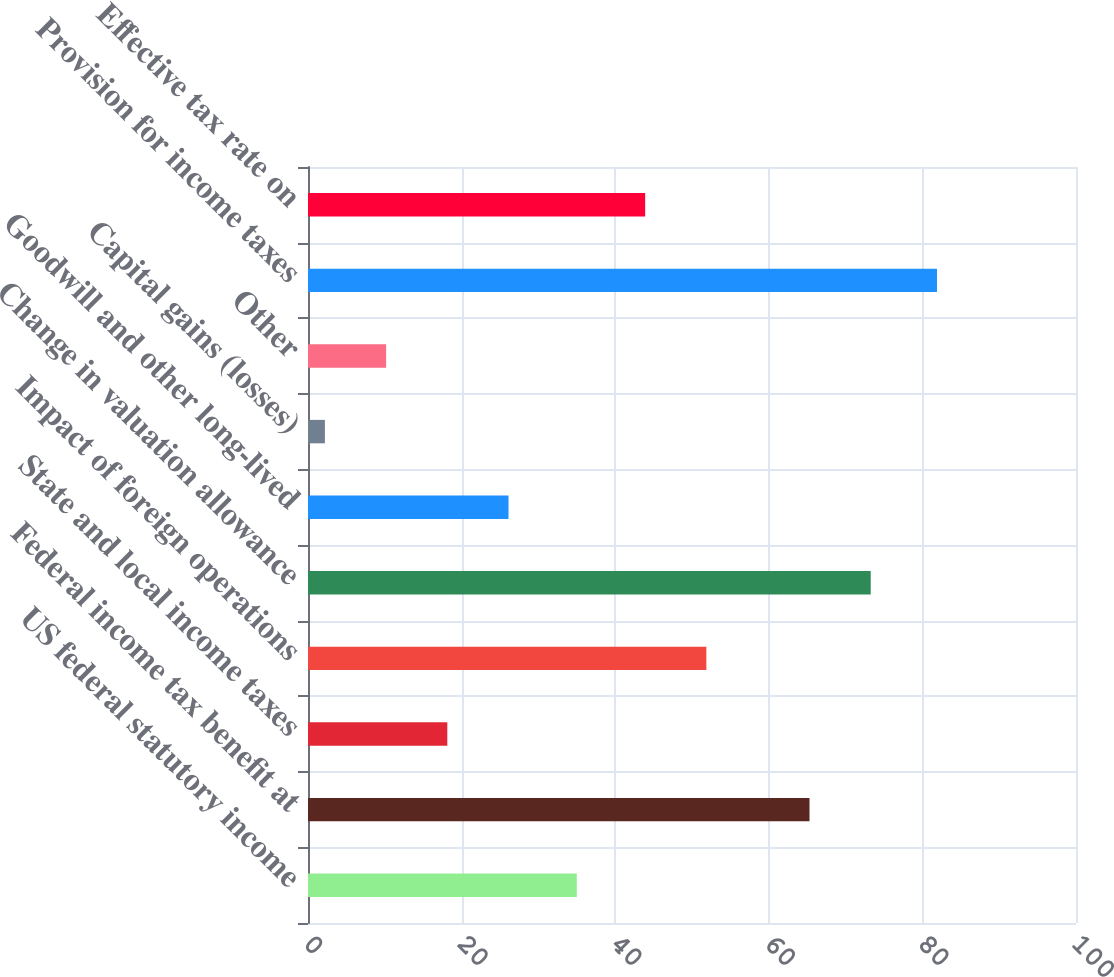Convert chart. <chart><loc_0><loc_0><loc_500><loc_500><bar_chart><fcel>US federal statutory income<fcel>Federal income tax benefit at<fcel>State and local income taxes<fcel>Impact of foreign operations<fcel>Change in valuation allowance<fcel>Goodwill and other long-lived<fcel>Capital gains (losses)<fcel>Other<fcel>Provision for income taxes<fcel>Effective tax rate on<nl><fcel>35<fcel>65.3<fcel>18.14<fcel>51.87<fcel>73.27<fcel>26.11<fcel>2.2<fcel>10.17<fcel>81.9<fcel>43.9<nl></chart> 